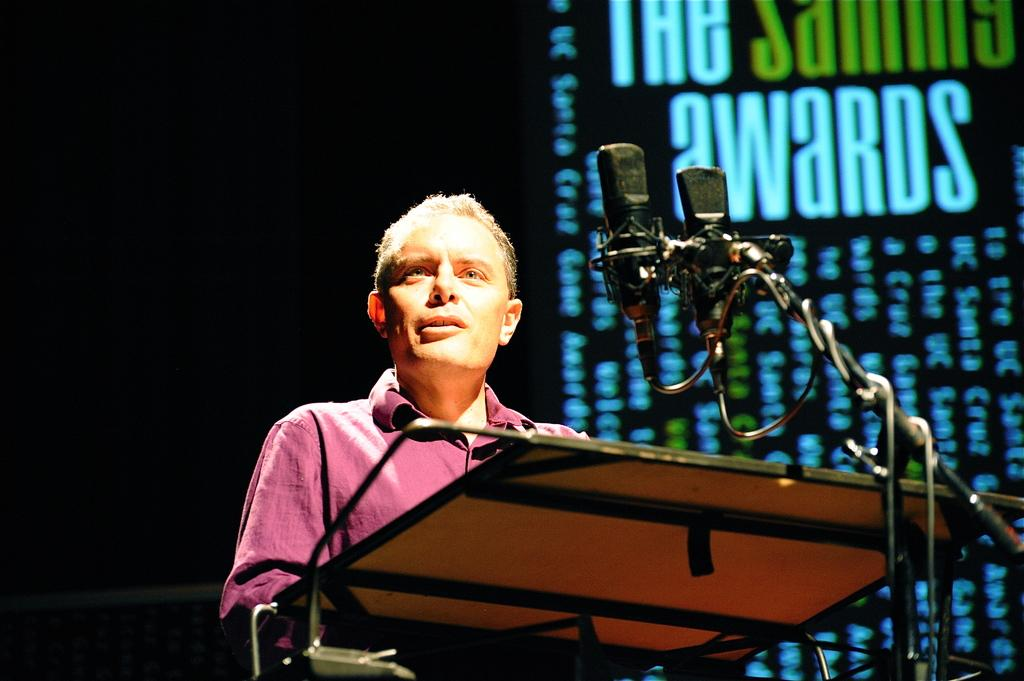What is the person in the image doing? The person is standing and talking into a microphone. What object can be seen near the person in the image? There is a stand in the image. What is present in the background of the image? There is a screen in the background of the image. Can you describe the lighting in the image? The background on the left side of the image is dark. What type of farm animals can be seen in the image? There are no farm animals present in the image. What color is the stocking on the person's leg in the image? The person in the image is not wearing a stocking, so there is no color to describe. 